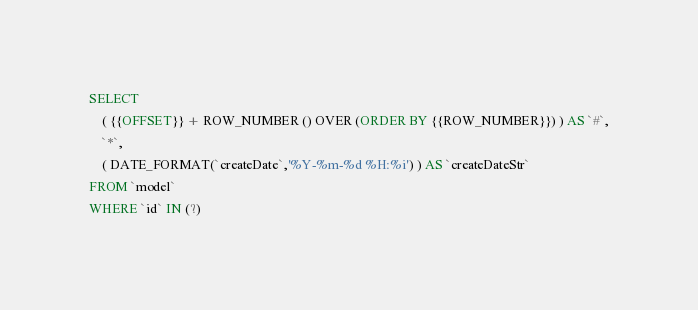<code> <loc_0><loc_0><loc_500><loc_500><_SQL_>SELECT 
    ( {{OFFSET}} + ROW_NUMBER () OVER (ORDER BY {{ROW_NUMBER}}) ) AS `#`,
    `*`,
    ( DATE_FORMAT(`createDate`,'%Y-%m-%d %H:%i') ) AS `createDateStr`
FROM `model`
WHERE `id` IN (?)</code> 